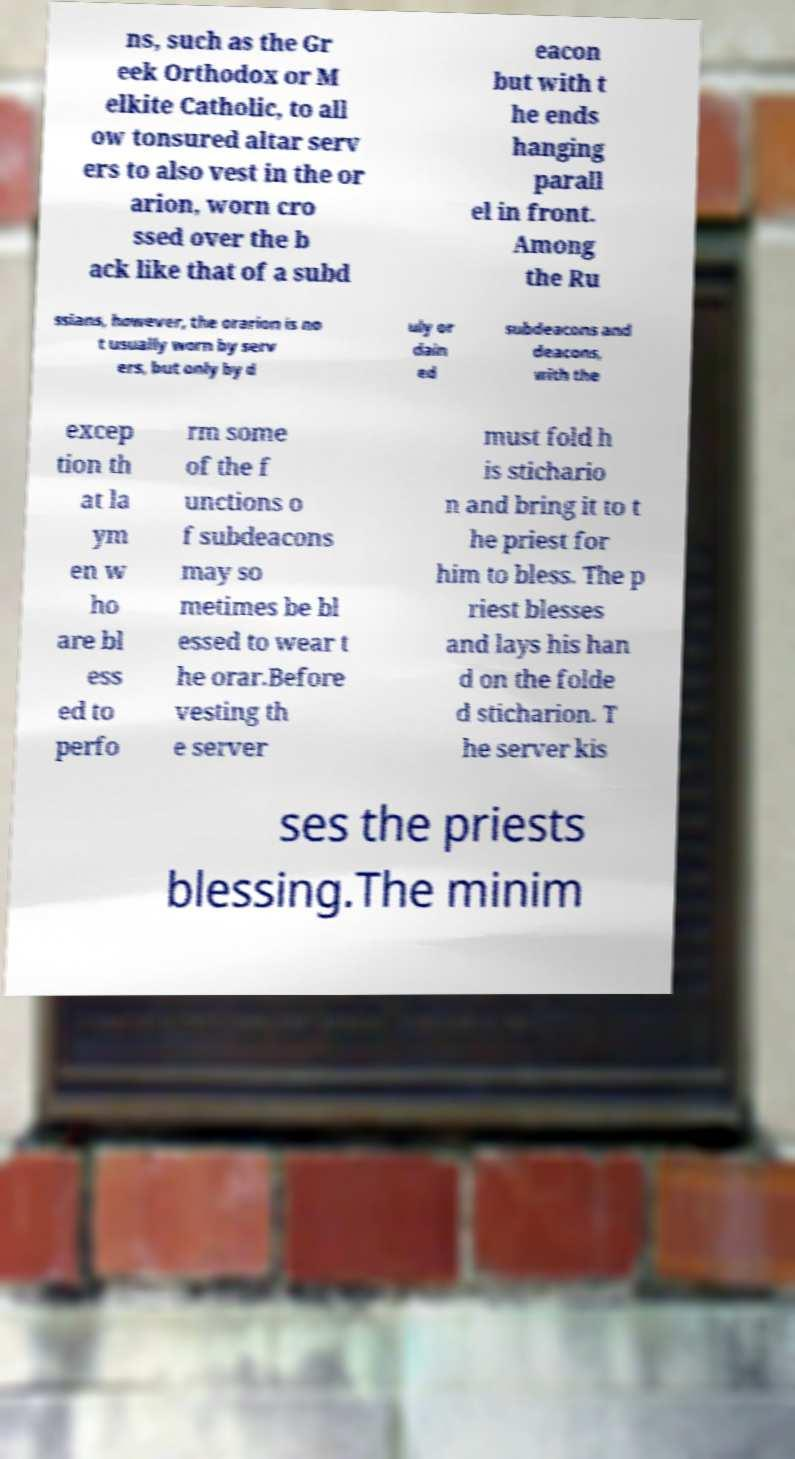Could you extract and type out the text from this image? ns, such as the Gr eek Orthodox or M elkite Catholic, to all ow tonsured altar serv ers to also vest in the or arion, worn cro ssed over the b ack like that of a subd eacon but with t he ends hanging parall el in front. Among the Ru ssians, however, the orarion is no t usually worn by serv ers, but only by d uly or dain ed subdeacons and deacons, with the excep tion th at la ym en w ho are bl ess ed to perfo rm some of the f unctions o f subdeacons may so metimes be bl essed to wear t he orar.Before vesting th e server must fold h is stichario n and bring it to t he priest for him to bless. The p riest blesses and lays his han d on the folde d sticharion. T he server kis ses the priests blessing.The minim 